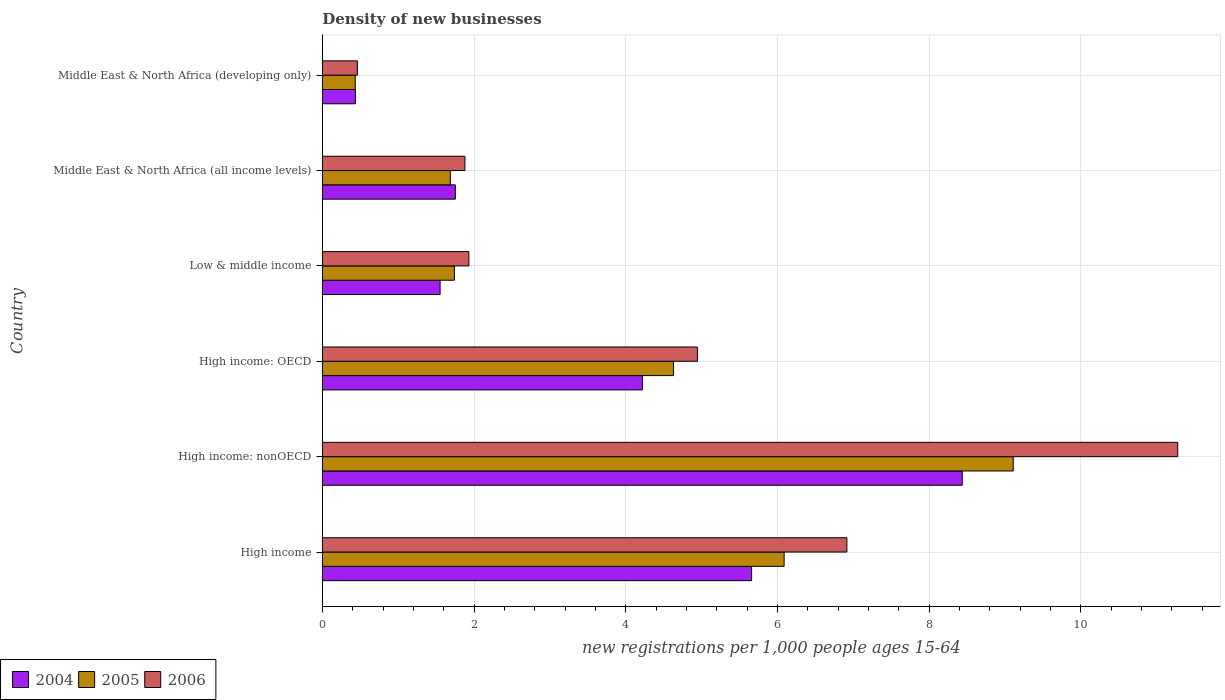How many different coloured bars are there?
Make the answer very short. 3. How many groups of bars are there?
Offer a terse response. 6. Are the number of bars per tick equal to the number of legend labels?
Your response must be concise. Yes. Are the number of bars on each tick of the Y-axis equal?
Keep it short and to the point. Yes. How many bars are there on the 5th tick from the bottom?
Keep it short and to the point. 3. What is the label of the 1st group of bars from the top?
Your answer should be compact. Middle East & North Africa (developing only). In how many cases, is the number of bars for a given country not equal to the number of legend labels?
Offer a terse response. 0. What is the number of new registrations in 2005 in Middle East & North Africa (all income levels)?
Offer a very short reply. 1.69. Across all countries, what is the maximum number of new registrations in 2004?
Ensure brevity in your answer.  8.44. Across all countries, what is the minimum number of new registrations in 2005?
Offer a very short reply. 0.43. In which country was the number of new registrations in 2004 maximum?
Your response must be concise. High income: nonOECD. In which country was the number of new registrations in 2006 minimum?
Keep it short and to the point. Middle East & North Africa (developing only). What is the total number of new registrations in 2005 in the graph?
Make the answer very short. 23.69. What is the difference between the number of new registrations in 2006 in Middle East & North Africa (all income levels) and that in Middle East & North Africa (developing only)?
Make the answer very short. 1.42. What is the difference between the number of new registrations in 2005 in High income: nonOECD and the number of new registrations in 2006 in Middle East & North Africa (all income levels)?
Your answer should be compact. 7.23. What is the average number of new registrations in 2006 per country?
Make the answer very short. 4.57. What is the difference between the number of new registrations in 2004 and number of new registrations in 2005 in High income: nonOECD?
Ensure brevity in your answer.  -0.67. What is the ratio of the number of new registrations in 2004 in Low & middle income to that in Middle East & North Africa (developing only)?
Offer a very short reply. 3.55. Is the difference between the number of new registrations in 2004 in High income: nonOECD and Low & middle income greater than the difference between the number of new registrations in 2005 in High income: nonOECD and Low & middle income?
Give a very brief answer. No. What is the difference between the highest and the second highest number of new registrations in 2004?
Make the answer very short. 2.78. What is the difference between the highest and the lowest number of new registrations in 2004?
Offer a very short reply. 8. In how many countries, is the number of new registrations in 2005 greater than the average number of new registrations in 2005 taken over all countries?
Give a very brief answer. 3. Is the sum of the number of new registrations in 2006 in High income and High income: nonOECD greater than the maximum number of new registrations in 2004 across all countries?
Offer a terse response. Yes. What does the 1st bar from the bottom in High income: OECD represents?
Keep it short and to the point. 2004. Is it the case that in every country, the sum of the number of new registrations in 2004 and number of new registrations in 2005 is greater than the number of new registrations in 2006?
Provide a short and direct response. Yes. How many bars are there?
Offer a terse response. 18. Are all the bars in the graph horizontal?
Your response must be concise. Yes. Does the graph contain any zero values?
Your answer should be compact. No. Does the graph contain grids?
Provide a short and direct response. Yes. Where does the legend appear in the graph?
Your response must be concise. Bottom left. How many legend labels are there?
Make the answer very short. 3. How are the legend labels stacked?
Make the answer very short. Horizontal. What is the title of the graph?
Provide a succinct answer. Density of new businesses. What is the label or title of the X-axis?
Provide a short and direct response. New registrations per 1,0 people ages 15-64. What is the new registrations per 1,000 people ages 15-64 of 2004 in High income?
Your response must be concise. 5.66. What is the new registrations per 1,000 people ages 15-64 of 2005 in High income?
Give a very brief answer. 6.09. What is the new registrations per 1,000 people ages 15-64 in 2006 in High income?
Your response must be concise. 6.91. What is the new registrations per 1,000 people ages 15-64 in 2004 in High income: nonOECD?
Make the answer very short. 8.44. What is the new registrations per 1,000 people ages 15-64 in 2005 in High income: nonOECD?
Ensure brevity in your answer.  9.11. What is the new registrations per 1,000 people ages 15-64 of 2006 in High income: nonOECD?
Keep it short and to the point. 11.28. What is the new registrations per 1,000 people ages 15-64 in 2004 in High income: OECD?
Your answer should be compact. 4.22. What is the new registrations per 1,000 people ages 15-64 of 2005 in High income: OECD?
Ensure brevity in your answer.  4.63. What is the new registrations per 1,000 people ages 15-64 of 2006 in High income: OECD?
Offer a very short reply. 4.94. What is the new registrations per 1,000 people ages 15-64 of 2004 in Low & middle income?
Provide a short and direct response. 1.55. What is the new registrations per 1,000 people ages 15-64 of 2005 in Low & middle income?
Offer a very short reply. 1.74. What is the new registrations per 1,000 people ages 15-64 of 2006 in Low & middle income?
Ensure brevity in your answer.  1.93. What is the new registrations per 1,000 people ages 15-64 in 2004 in Middle East & North Africa (all income levels)?
Give a very brief answer. 1.75. What is the new registrations per 1,000 people ages 15-64 of 2005 in Middle East & North Africa (all income levels)?
Your answer should be compact. 1.69. What is the new registrations per 1,000 people ages 15-64 in 2006 in Middle East & North Africa (all income levels)?
Make the answer very short. 1.88. What is the new registrations per 1,000 people ages 15-64 in 2004 in Middle East & North Africa (developing only)?
Your answer should be very brief. 0.44. What is the new registrations per 1,000 people ages 15-64 in 2005 in Middle East & North Africa (developing only)?
Offer a very short reply. 0.43. What is the new registrations per 1,000 people ages 15-64 in 2006 in Middle East & North Africa (developing only)?
Ensure brevity in your answer.  0.46. Across all countries, what is the maximum new registrations per 1,000 people ages 15-64 of 2004?
Give a very brief answer. 8.44. Across all countries, what is the maximum new registrations per 1,000 people ages 15-64 in 2005?
Ensure brevity in your answer.  9.11. Across all countries, what is the maximum new registrations per 1,000 people ages 15-64 in 2006?
Your answer should be compact. 11.28. Across all countries, what is the minimum new registrations per 1,000 people ages 15-64 in 2004?
Keep it short and to the point. 0.44. Across all countries, what is the minimum new registrations per 1,000 people ages 15-64 in 2005?
Make the answer very short. 0.43. Across all countries, what is the minimum new registrations per 1,000 people ages 15-64 in 2006?
Keep it short and to the point. 0.46. What is the total new registrations per 1,000 people ages 15-64 of 2004 in the graph?
Offer a very short reply. 22.06. What is the total new registrations per 1,000 people ages 15-64 in 2005 in the graph?
Your response must be concise. 23.69. What is the total new registrations per 1,000 people ages 15-64 in 2006 in the graph?
Ensure brevity in your answer.  27.41. What is the difference between the new registrations per 1,000 people ages 15-64 in 2004 in High income and that in High income: nonOECD?
Give a very brief answer. -2.78. What is the difference between the new registrations per 1,000 people ages 15-64 of 2005 in High income and that in High income: nonOECD?
Offer a very short reply. -3.02. What is the difference between the new registrations per 1,000 people ages 15-64 of 2006 in High income and that in High income: nonOECD?
Your answer should be very brief. -4.36. What is the difference between the new registrations per 1,000 people ages 15-64 of 2004 in High income and that in High income: OECD?
Make the answer very short. 1.44. What is the difference between the new registrations per 1,000 people ages 15-64 in 2005 in High income and that in High income: OECD?
Your answer should be compact. 1.46. What is the difference between the new registrations per 1,000 people ages 15-64 in 2006 in High income and that in High income: OECD?
Your answer should be compact. 1.97. What is the difference between the new registrations per 1,000 people ages 15-64 in 2004 in High income and that in Low & middle income?
Your response must be concise. 4.11. What is the difference between the new registrations per 1,000 people ages 15-64 of 2005 in High income and that in Low & middle income?
Provide a short and direct response. 4.35. What is the difference between the new registrations per 1,000 people ages 15-64 in 2006 in High income and that in Low & middle income?
Your answer should be very brief. 4.98. What is the difference between the new registrations per 1,000 people ages 15-64 in 2004 in High income and that in Middle East & North Africa (all income levels)?
Keep it short and to the point. 3.91. What is the difference between the new registrations per 1,000 people ages 15-64 of 2005 in High income and that in Middle East & North Africa (all income levels)?
Ensure brevity in your answer.  4.4. What is the difference between the new registrations per 1,000 people ages 15-64 of 2006 in High income and that in Middle East & North Africa (all income levels)?
Give a very brief answer. 5.04. What is the difference between the new registrations per 1,000 people ages 15-64 in 2004 in High income and that in Middle East & North Africa (developing only)?
Ensure brevity in your answer.  5.22. What is the difference between the new registrations per 1,000 people ages 15-64 of 2005 in High income and that in Middle East & North Africa (developing only)?
Provide a short and direct response. 5.65. What is the difference between the new registrations per 1,000 people ages 15-64 in 2006 in High income and that in Middle East & North Africa (developing only)?
Provide a short and direct response. 6.45. What is the difference between the new registrations per 1,000 people ages 15-64 in 2004 in High income: nonOECD and that in High income: OECD?
Offer a terse response. 4.22. What is the difference between the new registrations per 1,000 people ages 15-64 in 2005 in High income: nonOECD and that in High income: OECD?
Your answer should be very brief. 4.48. What is the difference between the new registrations per 1,000 people ages 15-64 of 2006 in High income: nonOECD and that in High income: OECD?
Provide a succinct answer. 6.33. What is the difference between the new registrations per 1,000 people ages 15-64 in 2004 in High income: nonOECD and that in Low & middle income?
Give a very brief answer. 6.88. What is the difference between the new registrations per 1,000 people ages 15-64 of 2005 in High income: nonOECD and that in Low & middle income?
Keep it short and to the point. 7.37. What is the difference between the new registrations per 1,000 people ages 15-64 in 2006 in High income: nonOECD and that in Low & middle income?
Your response must be concise. 9.34. What is the difference between the new registrations per 1,000 people ages 15-64 in 2004 in High income: nonOECD and that in Middle East & North Africa (all income levels)?
Your answer should be compact. 6.68. What is the difference between the new registrations per 1,000 people ages 15-64 in 2005 in High income: nonOECD and that in Middle East & North Africa (all income levels)?
Keep it short and to the point. 7.42. What is the difference between the new registrations per 1,000 people ages 15-64 of 2006 in High income: nonOECD and that in Middle East & North Africa (all income levels)?
Your response must be concise. 9.4. What is the difference between the new registrations per 1,000 people ages 15-64 of 2004 in High income: nonOECD and that in Middle East & North Africa (developing only)?
Offer a very short reply. 8. What is the difference between the new registrations per 1,000 people ages 15-64 in 2005 in High income: nonOECD and that in Middle East & North Africa (developing only)?
Make the answer very short. 8.67. What is the difference between the new registrations per 1,000 people ages 15-64 in 2006 in High income: nonOECD and that in Middle East & North Africa (developing only)?
Your answer should be compact. 10.81. What is the difference between the new registrations per 1,000 people ages 15-64 in 2004 in High income: OECD and that in Low & middle income?
Your answer should be very brief. 2.67. What is the difference between the new registrations per 1,000 people ages 15-64 of 2005 in High income: OECD and that in Low & middle income?
Offer a terse response. 2.89. What is the difference between the new registrations per 1,000 people ages 15-64 of 2006 in High income: OECD and that in Low & middle income?
Offer a very short reply. 3.01. What is the difference between the new registrations per 1,000 people ages 15-64 in 2004 in High income: OECD and that in Middle East & North Africa (all income levels)?
Your answer should be very brief. 2.47. What is the difference between the new registrations per 1,000 people ages 15-64 in 2005 in High income: OECD and that in Middle East & North Africa (all income levels)?
Make the answer very short. 2.94. What is the difference between the new registrations per 1,000 people ages 15-64 in 2006 in High income: OECD and that in Middle East & North Africa (all income levels)?
Make the answer very short. 3.07. What is the difference between the new registrations per 1,000 people ages 15-64 of 2004 in High income: OECD and that in Middle East & North Africa (developing only)?
Your answer should be very brief. 3.78. What is the difference between the new registrations per 1,000 people ages 15-64 of 2005 in High income: OECD and that in Middle East & North Africa (developing only)?
Your response must be concise. 4.2. What is the difference between the new registrations per 1,000 people ages 15-64 of 2006 in High income: OECD and that in Middle East & North Africa (developing only)?
Offer a terse response. 4.48. What is the difference between the new registrations per 1,000 people ages 15-64 in 2004 in Low & middle income and that in Middle East & North Africa (all income levels)?
Offer a terse response. -0.2. What is the difference between the new registrations per 1,000 people ages 15-64 in 2005 in Low & middle income and that in Middle East & North Africa (all income levels)?
Keep it short and to the point. 0.05. What is the difference between the new registrations per 1,000 people ages 15-64 in 2006 in Low & middle income and that in Middle East & North Africa (all income levels)?
Make the answer very short. 0.05. What is the difference between the new registrations per 1,000 people ages 15-64 of 2004 in Low & middle income and that in Middle East & North Africa (developing only)?
Offer a very short reply. 1.12. What is the difference between the new registrations per 1,000 people ages 15-64 in 2005 in Low & middle income and that in Middle East & North Africa (developing only)?
Make the answer very short. 1.31. What is the difference between the new registrations per 1,000 people ages 15-64 in 2006 in Low & middle income and that in Middle East & North Africa (developing only)?
Keep it short and to the point. 1.47. What is the difference between the new registrations per 1,000 people ages 15-64 in 2004 in Middle East & North Africa (all income levels) and that in Middle East & North Africa (developing only)?
Offer a terse response. 1.32. What is the difference between the new registrations per 1,000 people ages 15-64 in 2005 in Middle East & North Africa (all income levels) and that in Middle East & North Africa (developing only)?
Provide a short and direct response. 1.25. What is the difference between the new registrations per 1,000 people ages 15-64 in 2006 in Middle East & North Africa (all income levels) and that in Middle East & North Africa (developing only)?
Provide a short and direct response. 1.42. What is the difference between the new registrations per 1,000 people ages 15-64 of 2004 in High income and the new registrations per 1,000 people ages 15-64 of 2005 in High income: nonOECD?
Keep it short and to the point. -3.45. What is the difference between the new registrations per 1,000 people ages 15-64 of 2004 in High income and the new registrations per 1,000 people ages 15-64 of 2006 in High income: nonOECD?
Your answer should be very brief. -5.62. What is the difference between the new registrations per 1,000 people ages 15-64 in 2005 in High income and the new registrations per 1,000 people ages 15-64 in 2006 in High income: nonOECD?
Ensure brevity in your answer.  -5.19. What is the difference between the new registrations per 1,000 people ages 15-64 in 2004 in High income and the new registrations per 1,000 people ages 15-64 in 2005 in High income: OECD?
Offer a terse response. 1.03. What is the difference between the new registrations per 1,000 people ages 15-64 of 2004 in High income and the new registrations per 1,000 people ages 15-64 of 2006 in High income: OECD?
Your answer should be very brief. 0.71. What is the difference between the new registrations per 1,000 people ages 15-64 of 2005 in High income and the new registrations per 1,000 people ages 15-64 of 2006 in High income: OECD?
Offer a terse response. 1.14. What is the difference between the new registrations per 1,000 people ages 15-64 in 2004 in High income and the new registrations per 1,000 people ages 15-64 in 2005 in Low & middle income?
Offer a terse response. 3.92. What is the difference between the new registrations per 1,000 people ages 15-64 in 2004 in High income and the new registrations per 1,000 people ages 15-64 in 2006 in Low & middle income?
Make the answer very short. 3.73. What is the difference between the new registrations per 1,000 people ages 15-64 of 2005 in High income and the new registrations per 1,000 people ages 15-64 of 2006 in Low & middle income?
Your answer should be compact. 4.16. What is the difference between the new registrations per 1,000 people ages 15-64 of 2004 in High income and the new registrations per 1,000 people ages 15-64 of 2005 in Middle East & North Africa (all income levels)?
Your response must be concise. 3.97. What is the difference between the new registrations per 1,000 people ages 15-64 in 2004 in High income and the new registrations per 1,000 people ages 15-64 in 2006 in Middle East & North Africa (all income levels)?
Make the answer very short. 3.78. What is the difference between the new registrations per 1,000 people ages 15-64 of 2005 in High income and the new registrations per 1,000 people ages 15-64 of 2006 in Middle East & North Africa (all income levels)?
Your response must be concise. 4.21. What is the difference between the new registrations per 1,000 people ages 15-64 of 2004 in High income and the new registrations per 1,000 people ages 15-64 of 2005 in Middle East & North Africa (developing only)?
Provide a succinct answer. 5.22. What is the difference between the new registrations per 1,000 people ages 15-64 of 2004 in High income and the new registrations per 1,000 people ages 15-64 of 2006 in Middle East & North Africa (developing only)?
Provide a short and direct response. 5.2. What is the difference between the new registrations per 1,000 people ages 15-64 of 2005 in High income and the new registrations per 1,000 people ages 15-64 of 2006 in Middle East & North Africa (developing only)?
Your answer should be compact. 5.63. What is the difference between the new registrations per 1,000 people ages 15-64 in 2004 in High income: nonOECD and the new registrations per 1,000 people ages 15-64 in 2005 in High income: OECD?
Offer a very short reply. 3.81. What is the difference between the new registrations per 1,000 people ages 15-64 in 2004 in High income: nonOECD and the new registrations per 1,000 people ages 15-64 in 2006 in High income: OECD?
Provide a short and direct response. 3.49. What is the difference between the new registrations per 1,000 people ages 15-64 of 2005 in High income: nonOECD and the new registrations per 1,000 people ages 15-64 of 2006 in High income: OECD?
Your answer should be very brief. 4.16. What is the difference between the new registrations per 1,000 people ages 15-64 of 2004 in High income: nonOECD and the new registrations per 1,000 people ages 15-64 of 2005 in Low & middle income?
Ensure brevity in your answer.  6.69. What is the difference between the new registrations per 1,000 people ages 15-64 of 2004 in High income: nonOECD and the new registrations per 1,000 people ages 15-64 of 2006 in Low & middle income?
Your response must be concise. 6.5. What is the difference between the new registrations per 1,000 people ages 15-64 of 2005 in High income: nonOECD and the new registrations per 1,000 people ages 15-64 of 2006 in Low & middle income?
Provide a succinct answer. 7.18. What is the difference between the new registrations per 1,000 people ages 15-64 in 2004 in High income: nonOECD and the new registrations per 1,000 people ages 15-64 in 2005 in Middle East & North Africa (all income levels)?
Provide a short and direct response. 6.75. What is the difference between the new registrations per 1,000 people ages 15-64 of 2004 in High income: nonOECD and the new registrations per 1,000 people ages 15-64 of 2006 in Middle East & North Africa (all income levels)?
Offer a terse response. 6.56. What is the difference between the new registrations per 1,000 people ages 15-64 in 2005 in High income: nonOECD and the new registrations per 1,000 people ages 15-64 in 2006 in Middle East & North Africa (all income levels)?
Offer a very short reply. 7.23. What is the difference between the new registrations per 1,000 people ages 15-64 in 2004 in High income: nonOECD and the new registrations per 1,000 people ages 15-64 in 2005 in Middle East & North Africa (developing only)?
Provide a succinct answer. 8. What is the difference between the new registrations per 1,000 people ages 15-64 in 2004 in High income: nonOECD and the new registrations per 1,000 people ages 15-64 in 2006 in Middle East & North Africa (developing only)?
Your response must be concise. 7.97. What is the difference between the new registrations per 1,000 people ages 15-64 in 2005 in High income: nonOECD and the new registrations per 1,000 people ages 15-64 in 2006 in Middle East & North Africa (developing only)?
Give a very brief answer. 8.65. What is the difference between the new registrations per 1,000 people ages 15-64 in 2004 in High income: OECD and the new registrations per 1,000 people ages 15-64 in 2005 in Low & middle income?
Your answer should be compact. 2.48. What is the difference between the new registrations per 1,000 people ages 15-64 in 2004 in High income: OECD and the new registrations per 1,000 people ages 15-64 in 2006 in Low & middle income?
Give a very brief answer. 2.29. What is the difference between the new registrations per 1,000 people ages 15-64 of 2005 in High income: OECD and the new registrations per 1,000 people ages 15-64 of 2006 in Low & middle income?
Your answer should be very brief. 2.7. What is the difference between the new registrations per 1,000 people ages 15-64 in 2004 in High income: OECD and the new registrations per 1,000 people ages 15-64 in 2005 in Middle East & North Africa (all income levels)?
Your response must be concise. 2.53. What is the difference between the new registrations per 1,000 people ages 15-64 in 2004 in High income: OECD and the new registrations per 1,000 people ages 15-64 in 2006 in Middle East & North Africa (all income levels)?
Make the answer very short. 2.34. What is the difference between the new registrations per 1,000 people ages 15-64 in 2005 in High income: OECD and the new registrations per 1,000 people ages 15-64 in 2006 in Middle East & North Africa (all income levels)?
Provide a succinct answer. 2.75. What is the difference between the new registrations per 1,000 people ages 15-64 in 2004 in High income: OECD and the new registrations per 1,000 people ages 15-64 in 2005 in Middle East & North Africa (developing only)?
Provide a short and direct response. 3.79. What is the difference between the new registrations per 1,000 people ages 15-64 of 2004 in High income: OECD and the new registrations per 1,000 people ages 15-64 of 2006 in Middle East & North Africa (developing only)?
Your response must be concise. 3.76. What is the difference between the new registrations per 1,000 people ages 15-64 in 2005 in High income: OECD and the new registrations per 1,000 people ages 15-64 in 2006 in Middle East & North Africa (developing only)?
Provide a succinct answer. 4.17. What is the difference between the new registrations per 1,000 people ages 15-64 in 2004 in Low & middle income and the new registrations per 1,000 people ages 15-64 in 2005 in Middle East & North Africa (all income levels)?
Provide a short and direct response. -0.13. What is the difference between the new registrations per 1,000 people ages 15-64 in 2004 in Low & middle income and the new registrations per 1,000 people ages 15-64 in 2006 in Middle East & North Africa (all income levels)?
Provide a short and direct response. -0.33. What is the difference between the new registrations per 1,000 people ages 15-64 of 2005 in Low & middle income and the new registrations per 1,000 people ages 15-64 of 2006 in Middle East & North Africa (all income levels)?
Your response must be concise. -0.14. What is the difference between the new registrations per 1,000 people ages 15-64 of 2004 in Low & middle income and the new registrations per 1,000 people ages 15-64 of 2005 in Middle East & North Africa (developing only)?
Make the answer very short. 1.12. What is the difference between the new registrations per 1,000 people ages 15-64 in 2005 in Low & middle income and the new registrations per 1,000 people ages 15-64 in 2006 in Middle East & North Africa (developing only)?
Your answer should be compact. 1.28. What is the difference between the new registrations per 1,000 people ages 15-64 of 2004 in Middle East & North Africa (all income levels) and the new registrations per 1,000 people ages 15-64 of 2005 in Middle East & North Africa (developing only)?
Ensure brevity in your answer.  1.32. What is the difference between the new registrations per 1,000 people ages 15-64 in 2004 in Middle East & North Africa (all income levels) and the new registrations per 1,000 people ages 15-64 in 2006 in Middle East & North Africa (developing only)?
Offer a very short reply. 1.29. What is the difference between the new registrations per 1,000 people ages 15-64 in 2005 in Middle East & North Africa (all income levels) and the new registrations per 1,000 people ages 15-64 in 2006 in Middle East & North Africa (developing only)?
Your answer should be compact. 1.23. What is the average new registrations per 1,000 people ages 15-64 in 2004 per country?
Offer a terse response. 3.68. What is the average new registrations per 1,000 people ages 15-64 of 2005 per country?
Provide a succinct answer. 3.95. What is the average new registrations per 1,000 people ages 15-64 of 2006 per country?
Your response must be concise. 4.57. What is the difference between the new registrations per 1,000 people ages 15-64 in 2004 and new registrations per 1,000 people ages 15-64 in 2005 in High income?
Provide a short and direct response. -0.43. What is the difference between the new registrations per 1,000 people ages 15-64 in 2004 and new registrations per 1,000 people ages 15-64 in 2006 in High income?
Provide a short and direct response. -1.26. What is the difference between the new registrations per 1,000 people ages 15-64 in 2005 and new registrations per 1,000 people ages 15-64 in 2006 in High income?
Provide a succinct answer. -0.83. What is the difference between the new registrations per 1,000 people ages 15-64 of 2004 and new registrations per 1,000 people ages 15-64 of 2005 in High income: nonOECD?
Ensure brevity in your answer.  -0.67. What is the difference between the new registrations per 1,000 people ages 15-64 of 2004 and new registrations per 1,000 people ages 15-64 of 2006 in High income: nonOECD?
Give a very brief answer. -2.84. What is the difference between the new registrations per 1,000 people ages 15-64 in 2005 and new registrations per 1,000 people ages 15-64 in 2006 in High income: nonOECD?
Ensure brevity in your answer.  -2.17. What is the difference between the new registrations per 1,000 people ages 15-64 in 2004 and new registrations per 1,000 people ages 15-64 in 2005 in High income: OECD?
Your response must be concise. -0.41. What is the difference between the new registrations per 1,000 people ages 15-64 in 2004 and new registrations per 1,000 people ages 15-64 in 2006 in High income: OECD?
Ensure brevity in your answer.  -0.73. What is the difference between the new registrations per 1,000 people ages 15-64 in 2005 and new registrations per 1,000 people ages 15-64 in 2006 in High income: OECD?
Offer a very short reply. -0.32. What is the difference between the new registrations per 1,000 people ages 15-64 of 2004 and new registrations per 1,000 people ages 15-64 of 2005 in Low & middle income?
Provide a short and direct response. -0.19. What is the difference between the new registrations per 1,000 people ages 15-64 in 2004 and new registrations per 1,000 people ages 15-64 in 2006 in Low & middle income?
Provide a short and direct response. -0.38. What is the difference between the new registrations per 1,000 people ages 15-64 of 2005 and new registrations per 1,000 people ages 15-64 of 2006 in Low & middle income?
Keep it short and to the point. -0.19. What is the difference between the new registrations per 1,000 people ages 15-64 of 2004 and new registrations per 1,000 people ages 15-64 of 2005 in Middle East & North Africa (all income levels)?
Give a very brief answer. 0.07. What is the difference between the new registrations per 1,000 people ages 15-64 of 2004 and new registrations per 1,000 people ages 15-64 of 2006 in Middle East & North Africa (all income levels)?
Offer a terse response. -0.13. What is the difference between the new registrations per 1,000 people ages 15-64 in 2005 and new registrations per 1,000 people ages 15-64 in 2006 in Middle East & North Africa (all income levels)?
Your response must be concise. -0.19. What is the difference between the new registrations per 1,000 people ages 15-64 of 2004 and new registrations per 1,000 people ages 15-64 of 2005 in Middle East & North Africa (developing only)?
Keep it short and to the point. 0. What is the difference between the new registrations per 1,000 people ages 15-64 of 2004 and new registrations per 1,000 people ages 15-64 of 2006 in Middle East & North Africa (developing only)?
Make the answer very short. -0.02. What is the difference between the new registrations per 1,000 people ages 15-64 in 2005 and new registrations per 1,000 people ages 15-64 in 2006 in Middle East & North Africa (developing only)?
Your answer should be compact. -0.03. What is the ratio of the new registrations per 1,000 people ages 15-64 in 2004 in High income to that in High income: nonOECD?
Provide a short and direct response. 0.67. What is the ratio of the new registrations per 1,000 people ages 15-64 of 2005 in High income to that in High income: nonOECD?
Make the answer very short. 0.67. What is the ratio of the new registrations per 1,000 people ages 15-64 of 2006 in High income to that in High income: nonOECD?
Your answer should be very brief. 0.61. What is the ratio of the new registrations per 1,000 people ages 15-64 in 2004 in High income to that in High income: OECD?
Offer a terse response. 1.34. What is the ratio of the new registrations per 1,000 people ages 15-64 of 2005 in High income to that in High income: OECD?
Offer a terse response. 1.31. What is the ratio of the new registrations per 1,000 people ages 15-64 in 2006 in High income to that in High income: OECD?
Your answer should be compact. 1.4. What is the ratio of the new registrations per 1,000 people ages 15-64 in 2004 in High income to that in Low & middle income?
Your response must be concise. 3.64. What is the ratio of the new registrations per 1,000 people ages 15-64 of 2005 in High income to that in Low & middle income?
Provide a short and direct response. 3.5. What is the ratio of the new registrations per 1,000 people ages 15-64 in 2006 in High income to that in Low & middle income?
Your answer should be compact. 3.58. What is the ratio of the new registrations per 1,000 people ages 15-64 of 2004 in High income to that in Middle East & North Africa (all income levels)?
Offer a very short reply. 3.23. What is the ratio of the new registrations per 1,000 people ages 15-64 of 2005 in High income to that in Middle East & North Africa (all income levels)?
Ensure brevity in your answer.  3.61. What is the ratio of the new registrations per 1,000 people ages 15-64 in 2006 in High income to that in Middle East & North Africa (all income levels)?
Your answer should be compact. 3.68. What is the ratio of the new registrations per 1,000 people ages 15-64 in 2004 in High income to that in Middle East & North Africa (developing only)?
Offer a terse response. 12.96. What is the ratio of the new registrations per 1,000 people ages 15-64 of 2005 in High income to that in Middle East & North Africa (developing only)?
Give a very brief answer. 14.03. What is the ratio of the new registrations per 1,000 people ages 15-64 of 2006 in High income to that in Middle East & North Africa (developing only)?
Offer a very short reply. 14.98. What is the ratio of the new registrations per 1,000 people ages 15-64 in 2004 in High income: nonOECD to that in High income: OECD?
Give a very brief answer. 2. What is the ratio of the new registrations per 1,000 people ages 15-64 of 2005 in High income: nonOECD to that in High income: OECD?
Provide a succinct answer. 1.97. What is the ratio of the new registrations per 1,000 people ages 15-64 in 2006 in High income: nonOECD to that in High income: OECD?
Provide a short and direct response. 2.28. What is the ratio of the new registrations per 1,000 people ages 15-64 of 2004 in High income: nonOECD to that in Low & middle income?
Your answer should be very brief. 5.43. What is the ratio of the new registrations per 1,000 people ages 15-64 in 2005 in High income: nonOECD to that in Low & middle income?
Your response must be concise. 5.23. What is the ratio of the new registrations per 1,000 people ages 15-64 of 2006 in High income: nonOECD to that in Low & middle income?
Your response must be concise. 5.84. What is the ratio of the new registrations per 1,000 people ages 15-64 of 2004 in High income: nonOECD to that in Middle East & North Africa (all income levels)?
Your answer should be very brief. 4.81. What is the ratio of the new registrations per 1,000 people ages 15-64 in 2005 in High income: nonOECD to that in Middle East & North Africa (all income levels)?
Your answer should be compact. 5.4. What is the ratio of the new registrations per 1,000 people ages 15-64 of 2006 in High income: nonOECD to that in Middle East & North Africa (all income levels)?
Your answer should be compact. 6. What is the ratio of the new registrations per 1,000 people ages 15-64 of 2004 in High income: nonOECD to that in Middle East & North Africa (developing only)?
Your answer should be very brief. 19.31. What is the ratio of the new registrations per 1,000 people ages 15-64 of 2005 in High income: nonOECD to that in Middle East & North Africa (developing only)?
Your answer should be very brief. 20.99. What is the ratio of the new registrations per 1,000 people ages 15-64 in 2006 in High income: nonOECD to that in Middle East & North Africa (developing only)?
Ensure brevity in your answer.  24.42. What is the ratio of the new registrations per 1,000 people ages 15-64 of 2004 in High income: OECD to that in Low & middle income?
Your answer should be very brief. 2.72. What is the ratio of the new registrations per 1,000 people ages 15-64 in 2005 in High income: OECD to that in Low & middle income?
Ensure brevity in your answer.  2.66. What is the ratio of the new registrations per 1,000 people ages 15-64 of 2006 in High income: OECD to that in Low & middle income?
Your answer should be very brief. 2.56. What is the ratio of the new registrations per 1,000 people ages 15-64 of 2004 in High income: OECD to that in Middle East & North Africa (all income levels)?
Make the answer very short. 2.41. What is the ratio of the new registrations per 1,000 people ages 15-64 of 2005 in High income: OECD to that in Middle East & North Africa (all income levels)?
Keep it short and to the point. 2.74. What is the ratio of the new registrations per 1,000 people ages 15-64 of 2006 in High income: OECD to that in Middle East & North Africa (all income levels)?
Your answer should be very brief. 2.63. What is the ratio of the new registrations per 1,000 people ages 15-64 of 2004 in High income: OECD to that in Middle East & North Africa (developing only)?
Keep it short and to the point. 9.66. What is the ratio of the new registrations per 1,000 people ages 15-64 of 2005 in High income: OECD to that in Middle East & North Africa (developing only)?
Provide a short and direct response. 10.67. What is the ratio of the new registrations per 1,000 people ages 15-64 of 2006 in High income: OECD to that in Middle East & North Africa (developing only)?
Keep it short and to the point. 10.71. What is the ratio of the new registrations per 1,000 people ages 15-64 of 2004 in Low & middle income to that in Middle East & North Africa (all income levels)?
Keep it short and to the point. 0.89. What is the ratio of the new registrations per 1,000 people ages 15-64 in 2005 in Low & middle income to that in Middle East & North Africa (all income levels)?
Ensure brevity in your answer.  1.03. What is the ratio of the new registrations per 1,000 people ages 15-64 of 2006 in Low & middle income to that in Middle East & North Africa (all income levels)?
Make the answer very short. 1.03. What is the ratio of the new registrations per 1,000 people ages 15-64 in 2004 in Low & middle income to that in Middle East & North Africa (developing only)?
Your response must be concise. 3.55. What is the ratio of the new registrations per 1,000 people ages 15-64 in 2005 in Low & middle income to that in Middle East & North Africa (developing only)?
Keep it short and to the point. 4.01. What is the ratio of the new registrations per 1,000 people ages 15-64 in 2006 in Low & middle income to that in Middle East & North Africa (developing only)?
Provide a succinct answer. 4.18. What is the ratio of the new registrations per 1,000 people ages 15-64 of 2004 in Middle East & North Africa (all income levels) to that in Middle East & North Africa (developing only)?
Your response must be concise. 4.01. What is the ratio of the new registrations per 1,000 people ages 15-64 of 2005 in Middle East & North Africa (all income levels) to that in Middle East & North Africa (developing only)?
Offer a terse response. 3.89. What is the ratio of the new registrations per 1,000 people ages 15-64 of 2006 in Middle East & North Africa (all income levels) to that in Middle East & North Africa (developing only)?
Offer a terse response. 4.07. What is the difference between the highest and the second highest new registrations per 1,000 people ages 15-64 in 2004?
Your response must be concise. 2.78. What is the difference between the highest and the second highest new registrations per 1,000 people ages 15-64 in 2005?
Ensure brevity in your answer.  3.02. What is the difference between the highest and the second highest new registrations per 1,000 people ages 15-64 of 2006?
Your response must be concise. 4.36. What is the difference between the highest and the lowest new registrations per 1,000 people ages 15-64 in 2004?
Give a very brief answer. 8. What is the difference between the highest and the lowest new registrations per 1,000 people ages 15-64 in 2005?
Your response must be concise. 8.67. What is the difference between the highest and the lowest new registrations per 1,000 people ages 15-64 of 2006?
Offer a very short reply. 10.81. 